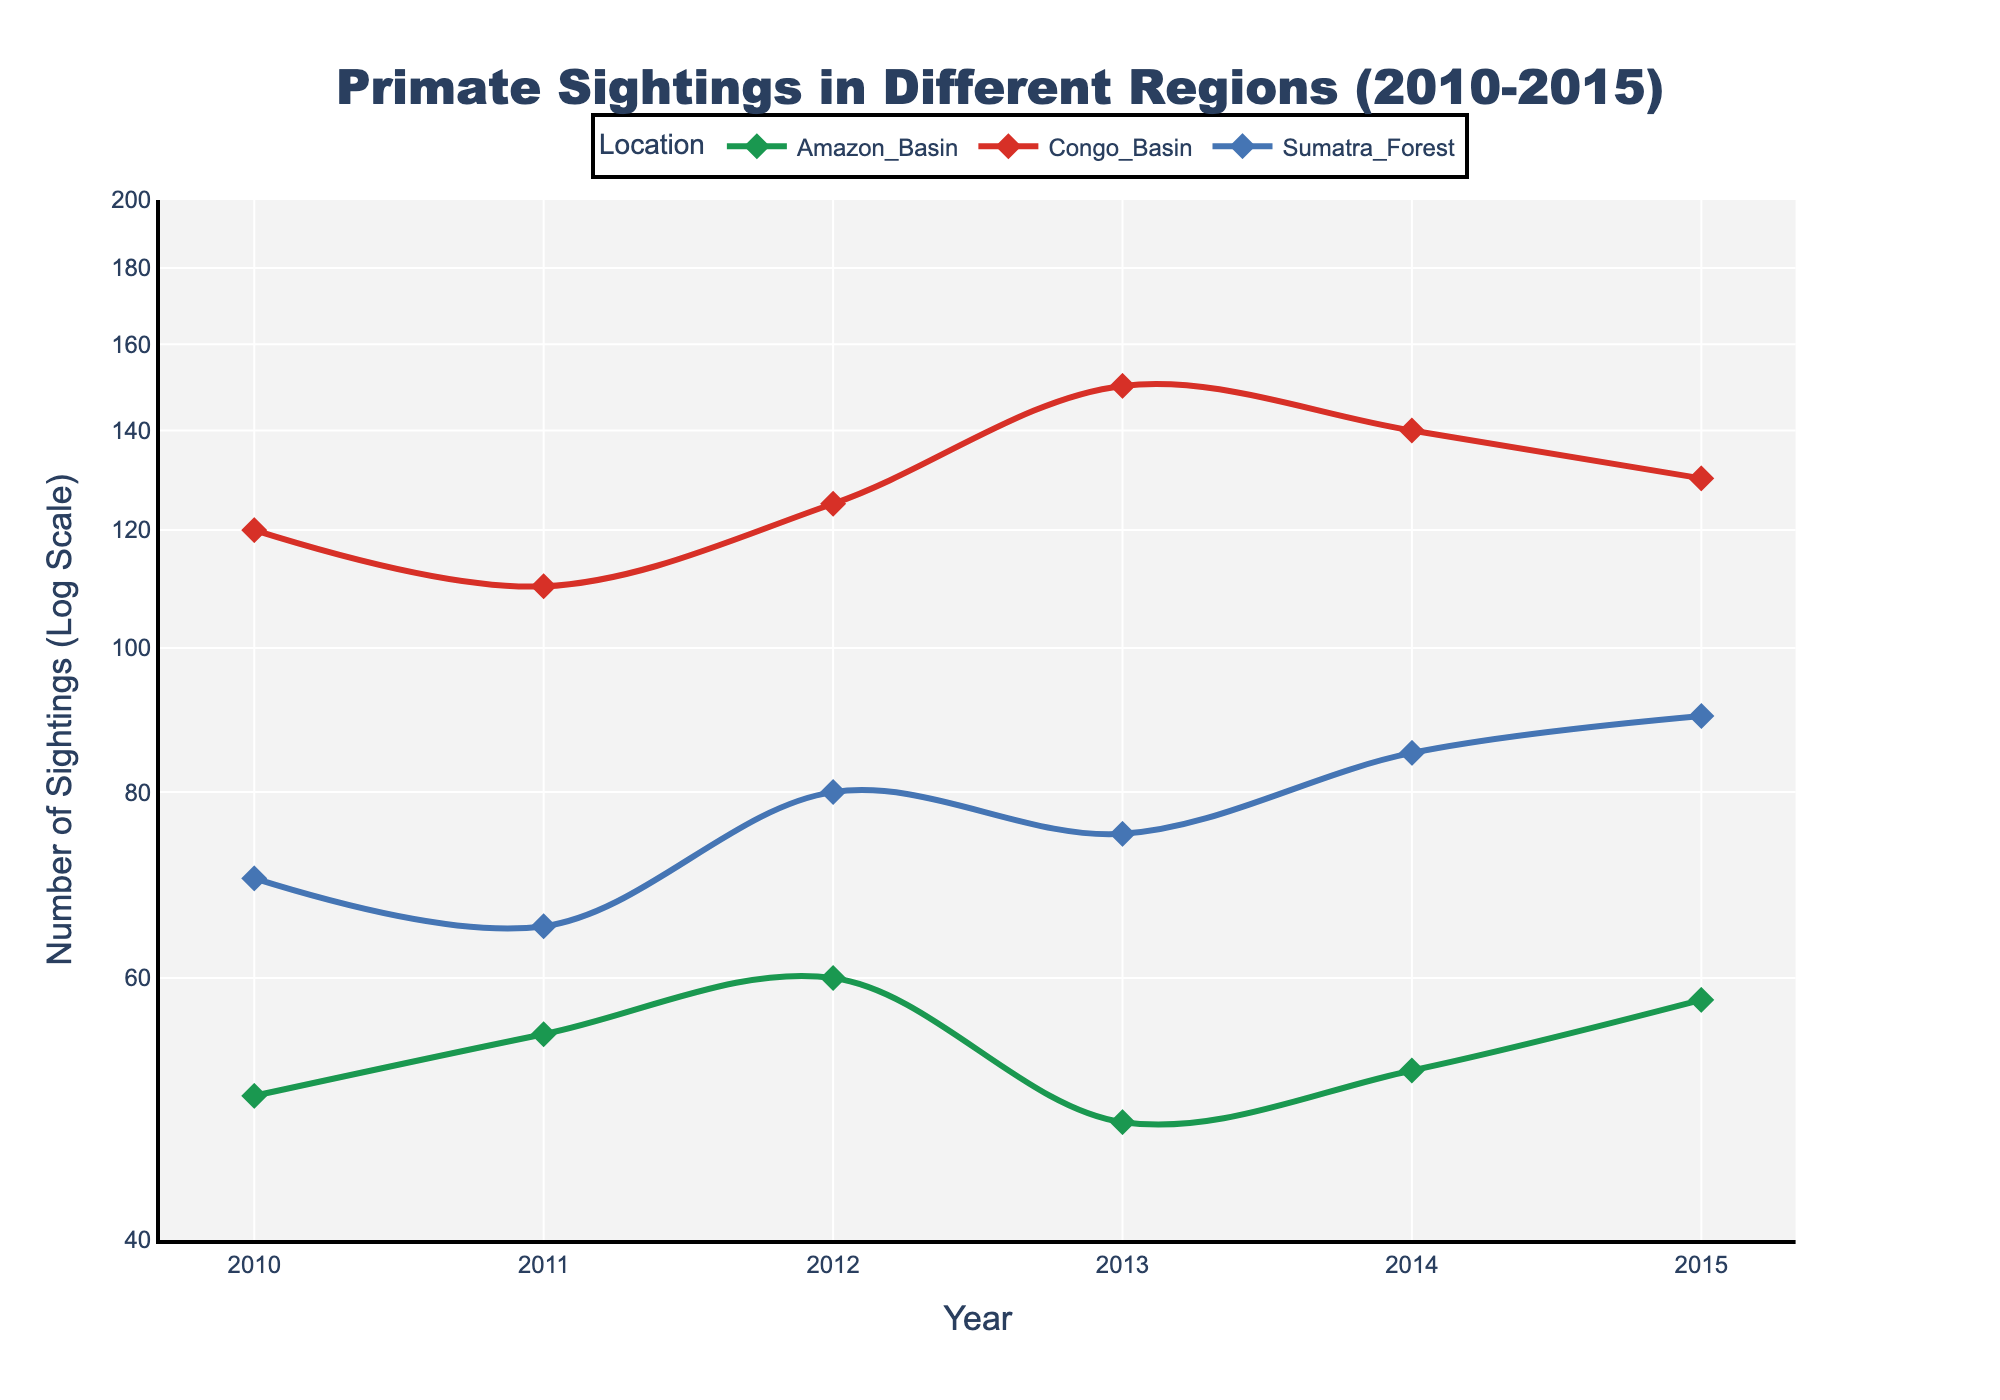How many years are covered in the plot? The x-axis shows labeled years from 2010 to 2015, which indicates the range of the data. Therefore, counting all the labels from 2010 to 2015 gives us a total of 6 years.
Answer: 6 What is the title of the plot? The plot title is located at the top and is usually more prominent and larger in size. In this case, the title states, "Primate Sightings in Different Regions (2010-2015)."
Answer: Primate Sightings in Different Regions (2010-2015) Which location has the highest number of sightings in 2014? Refer to the data points for each location at the year 2014. The Congo Basin shows about 140 sightings, which is the highest compared to the other locations for that year.
Answer: Congo Basin What's the trend of primate sightings in the Amazon Basin from 2010 to 2015? Observe the data points for the Amazon Basin from 2010 to 2015. Starting at 50 in 2010, the numbers generally increase but exhibit minor fluctuations, ending at 58 in 2015.
Answer: Generally increasing, with minor fluctuations Compare the number of primate sightings between Congo Basin and Sumatra Forest in 2012. Which one has more sightings and by how much? For 2012, Congo Basin sighting is 125, while Sumatra Forest sighting is 80. Subtract 80 from 125 to find the difference.
Answer: Congo Basin by 45 sightings What is the overall pattern in the number of primate sightings for the Congo Basin from 2010 to 2015? Check the data points for Congo Basin from 2010 to 2015. Sightings start at 120, fluctuate slightly, but the trend is overall increasing, peaking at 150 in 2013 before slightly descending.
Answer: Generally increasing with a peak in 2013 Is the y-axis on a linear or logarithmic scale? The y-axis title specifies "Number of Sightings (Log Scale)." This indicates that the y-axis is logarithmic.
Answer: Logarithmic scale What was the percentage increase in sightings in Sumatra Forest from 2013 to 2014? For Sumatra Forest, sightings were 75 in 2013 and increased to 85 in 2014. The percentage increase is calculated by ((85 - 75) / 75) * 100%.
Answer: 13.33% Which year's data shows the largest number of primate sightings across all locations, and what is that number? Spot the year where the highest data point exists. In 2013, the Congo Basin has the highest number at 150 sightings, which is the maximal value observed in this dataset.
Answer: 2013, 150 How does the number of sightings in the Amazon Basin in 2013 compare to 2010? Sightings in the Amazon Basin in 2010 are 50 and in 2013 are 48. Compare by subtracting the numbers to determine the difference.
Answer: Decreased by 2 